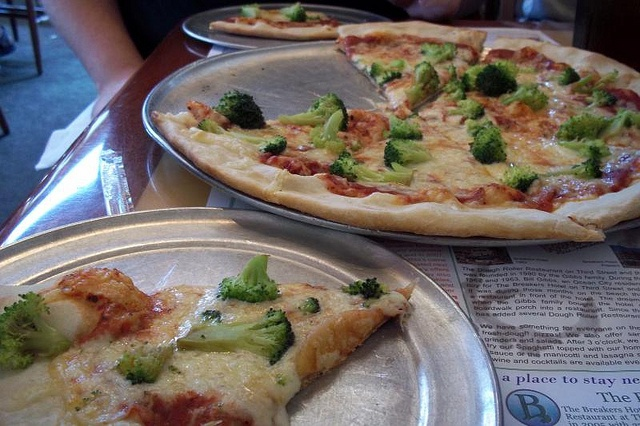Describe the objects in this image and their specific colors. I can see dining table in darkgray, gray, darkblue, and black tones, pizza in darkblue, olive, and gray tones, pizza in darkblue, tan, gray, darkgray, and olive tones, pizza in darkblue, olive, gray, and tan tones, and broccoli in darkblue, darkgreen, black, and olive tones in this image. 